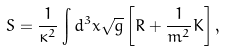Convert formula to latex. <formula><loc_0><loc_0><loc_500><loc_500>S = \frac { 1 } { \kappa ^ { 2 } } \int d ^ { 3 } x \sqrt { g } \left [ R + \frac { 1 } { m ^ { 2 } } K \right ] ,</formula> 